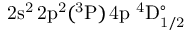Convert formula to latex. <formula><loc_0><loc_0><loc_500><loc_500>2 s ^ { 2 } \, 2 p ^ { 2 } ( ^ { 3 } P ) \, 4 p ^ { 4 } D _ { 1 / 2 } ^ { \circ }</formula> 